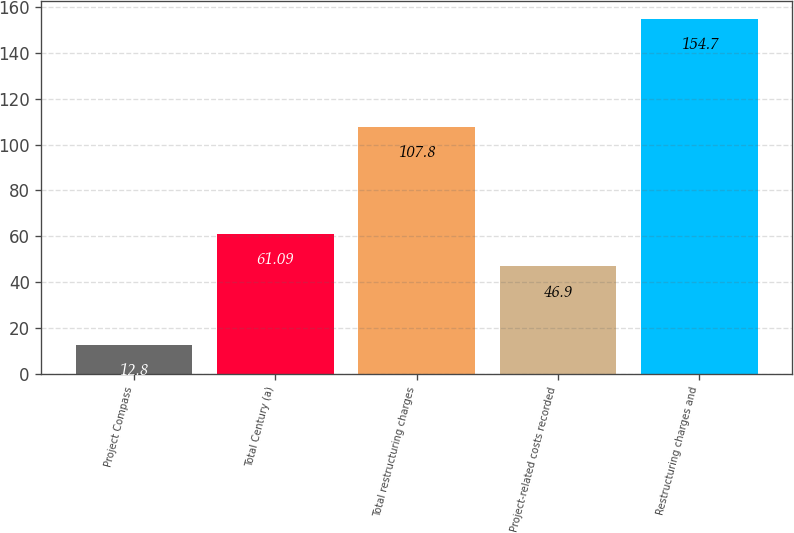Convert chart to OTSL. <chart><loc_0><loc_0><loc_500><loc_500><bar_chart><fcel>Project Compass<fcel>Total Century (a)<fcel>Total restructuring charges<fcel>Project-related costs recorded<fcel>Restructuring charges and<nl><fcel>12.8<fcel>61.09<fcel>107.8<fcel>46.9<fcel>154.7<nl></chart> 